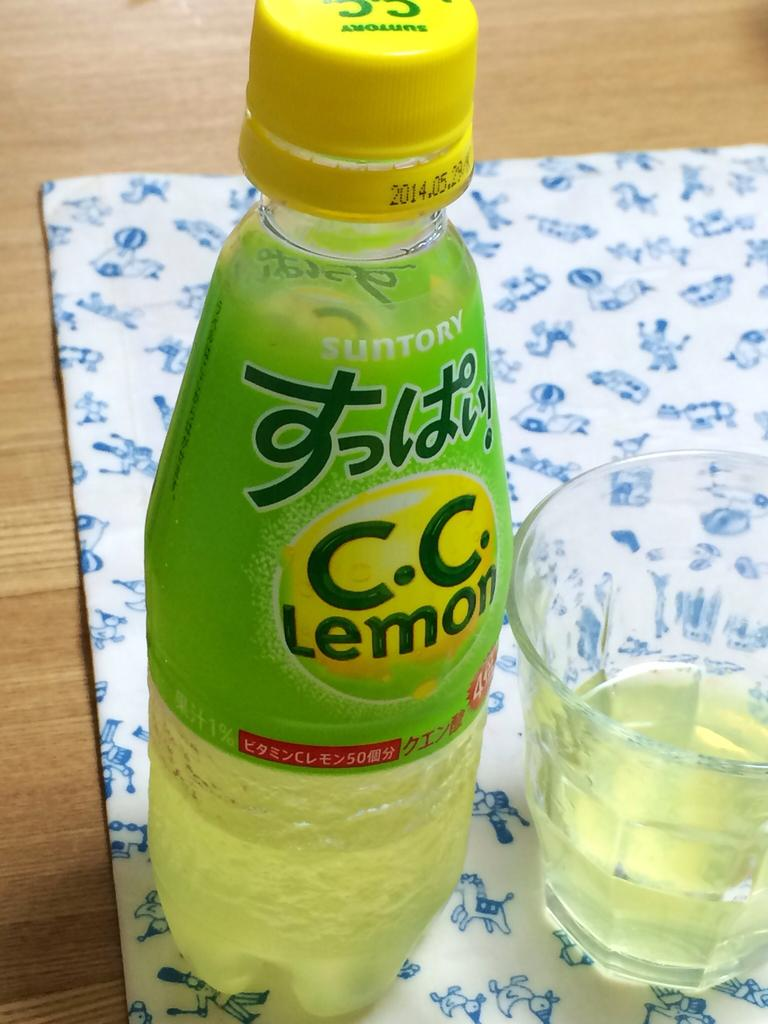Provide a one-sentence caption for the provided image. A C.C. Lemon bottle is on a table next to a glass. 